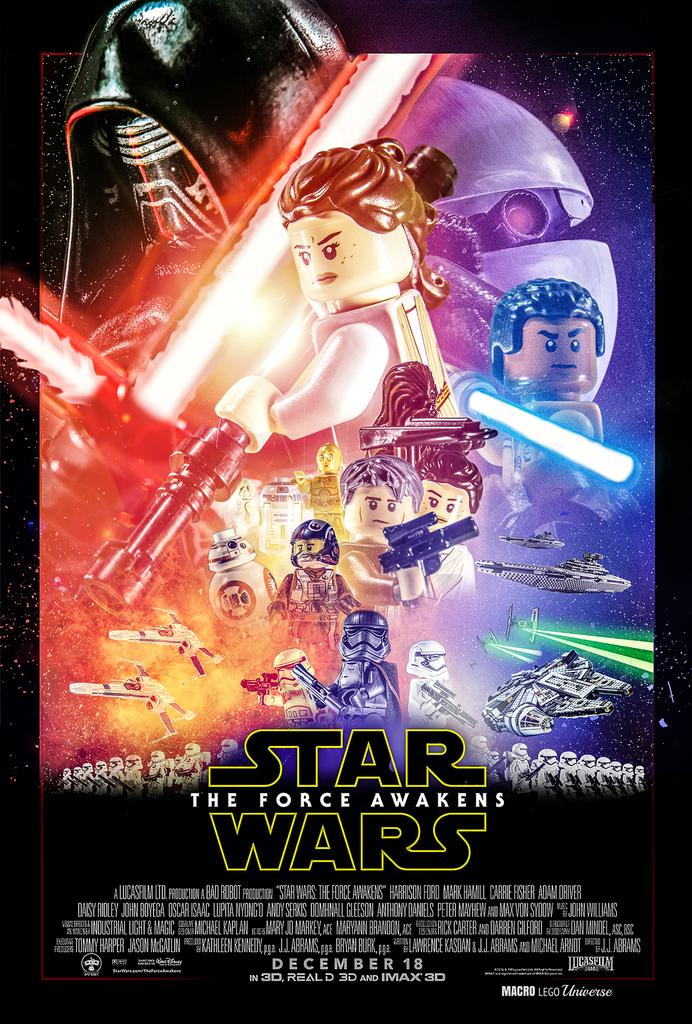<image>
Offer a succinct explanation of the picture presented. a Lego Star Wars poster with the characters on it 